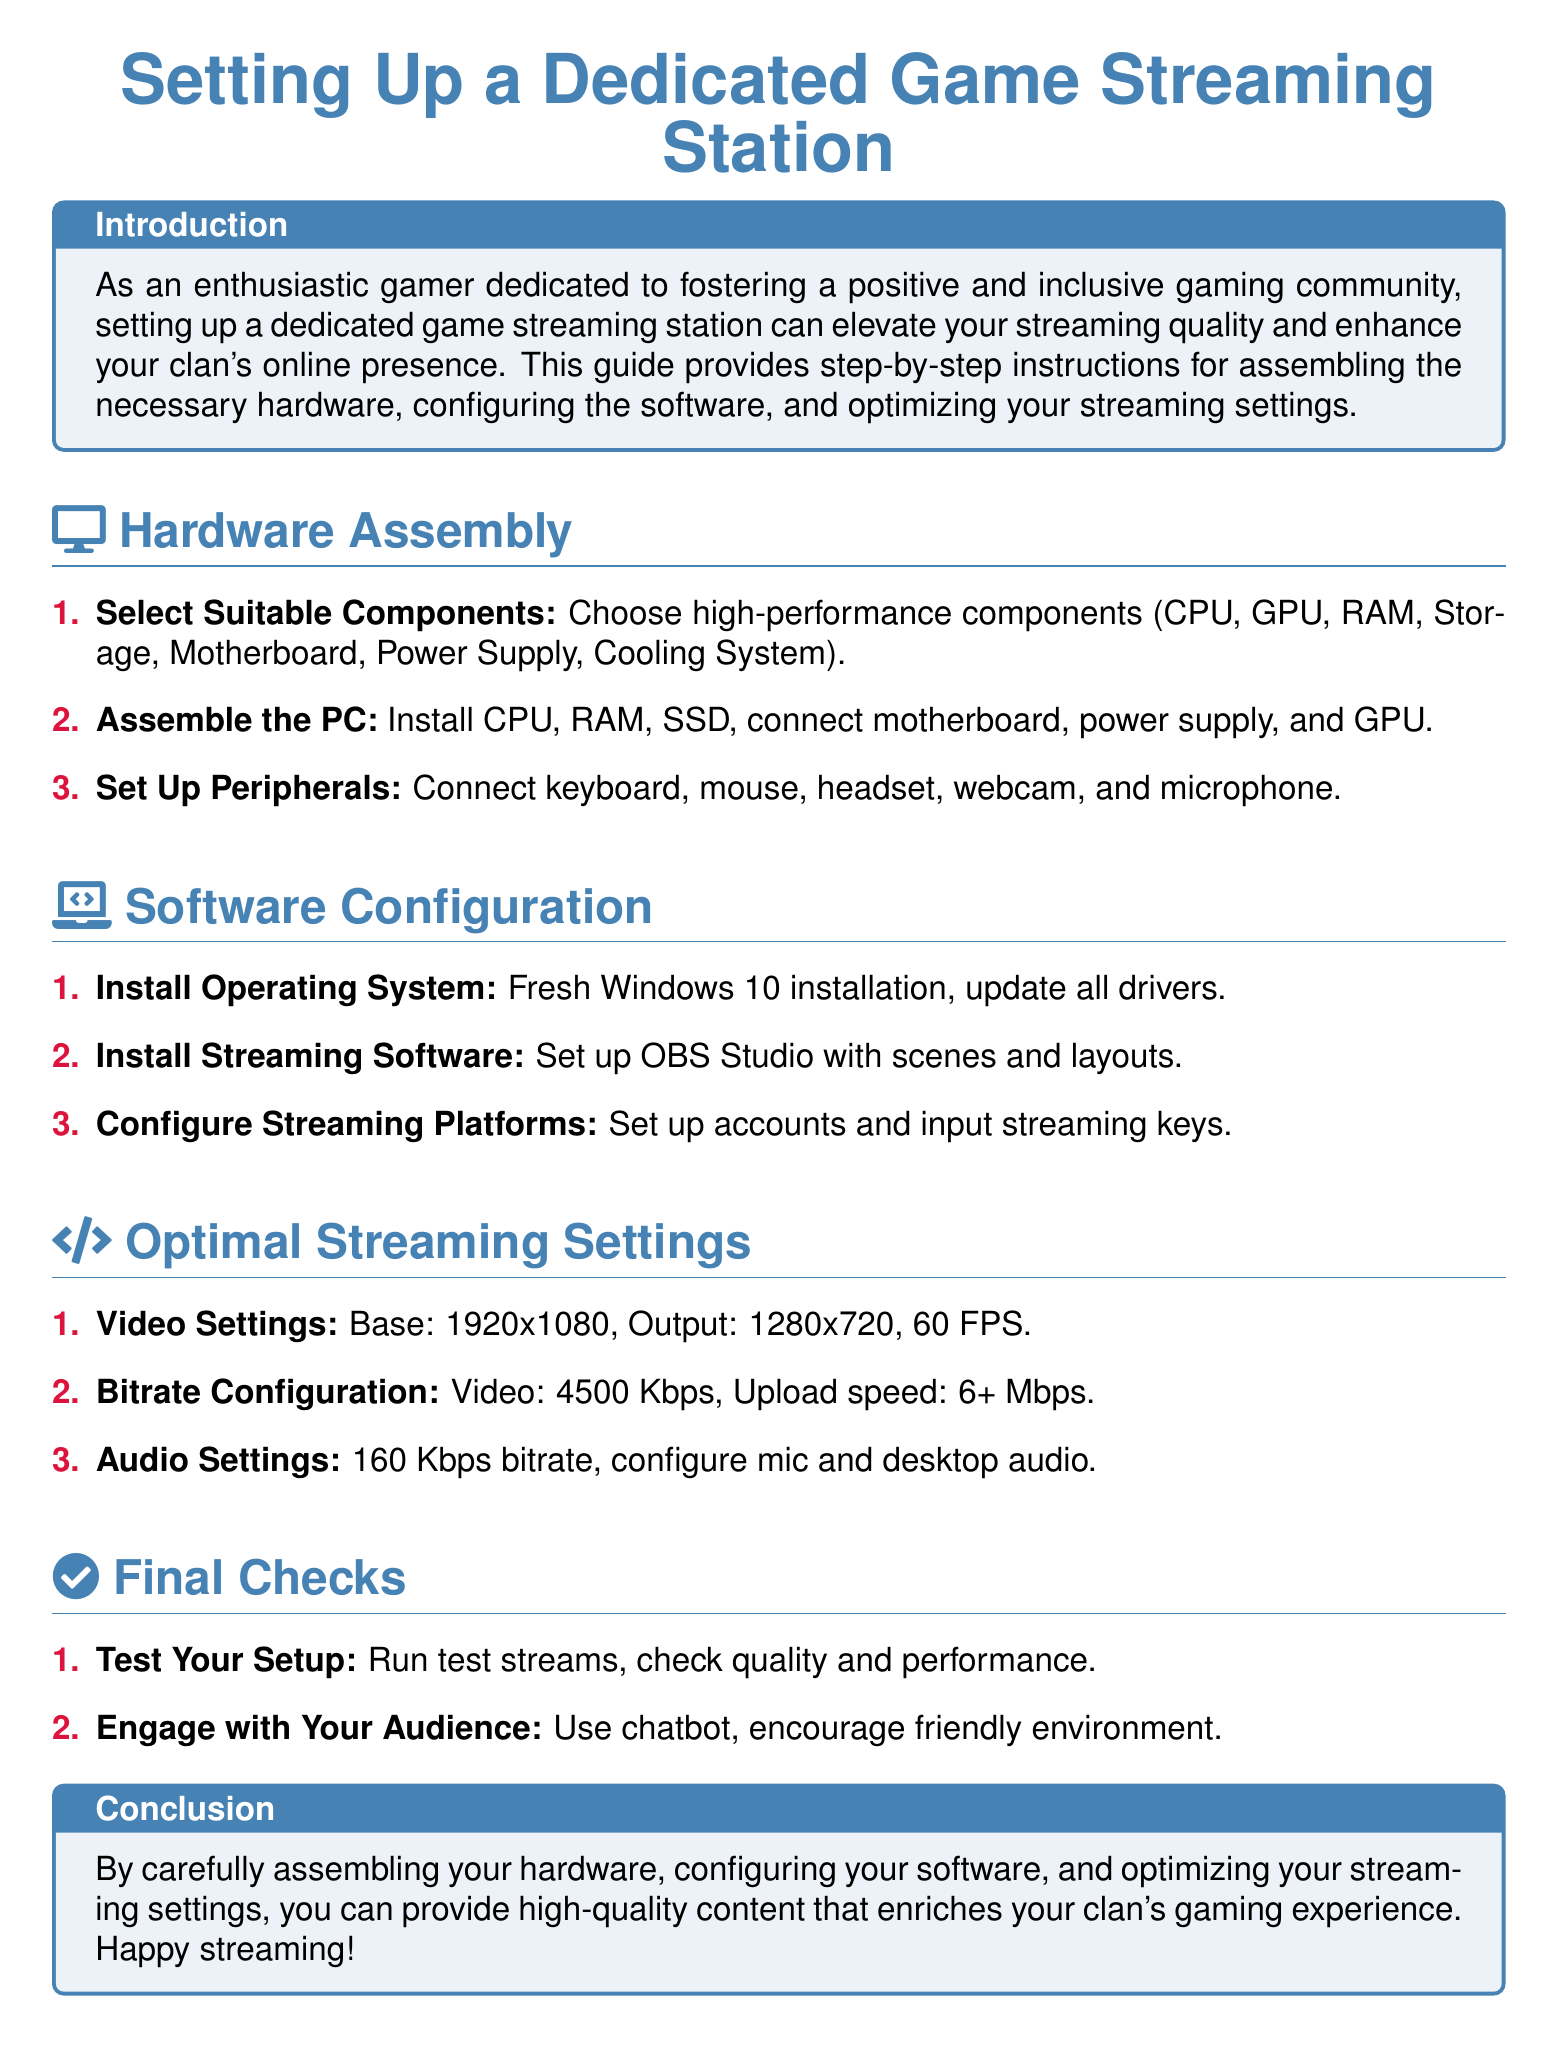what is the main purpose of the document? The main purpose is to provide instructions for setting up a dedicated game streaming station to improve streaming quality.
Answer: improve streaming quality what operating system should be installed? The document specifies installing a fresh version of Windows 10.
Answer: Windows 10 what is the output resolution recommended for video settings? The recommended output resolution for video settings is 1280x720.
Answer: 1280x720 how many steps are there in the Hardware Assembly section? There are three steps listed in the Hardware Assembly section.
Answer: three what is the recommended video bitrate? The document recommends a video bitrate of 4500 Kbps.
Answer: 4500 Kbps which streaming software is suggested in the document? The suggested streaming software mentioned in the document is OBS Studio.
Answer: OBS Studio what should you do to engage with your audience? The document suggests using a chatbot to engage with your audience.
Answer: use chatbot what is the recommended upload speed for streaming? The recommended upload speed for streaming is 6+ Mbps.
Answer: 6+ Mbps how many steps are included in the Final Checks section? The Final Checks section includes two steps.
Answer: two 